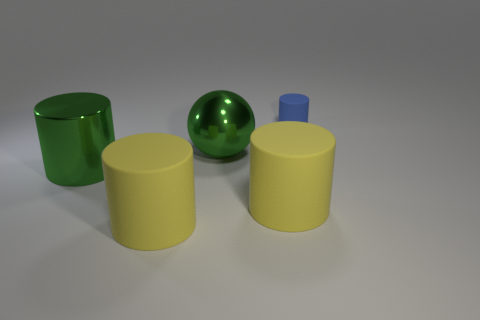Subtract 1 cylinders. How many cylinders are left? 3 Add 5 big yellow cylinders. How many objects exist? 10 Subtract all balls. How many objects are left? 4 Subtract all shiny objects. Subtract all big green metallic things. How many objects are left? 1 Add 2 large yellow cylinders. How many large yellow cylinders are left? 4 Add 3 large green objects. How many large green objects exist? 5 Subtract 0 yellow spheres. How many objects are left? 5 